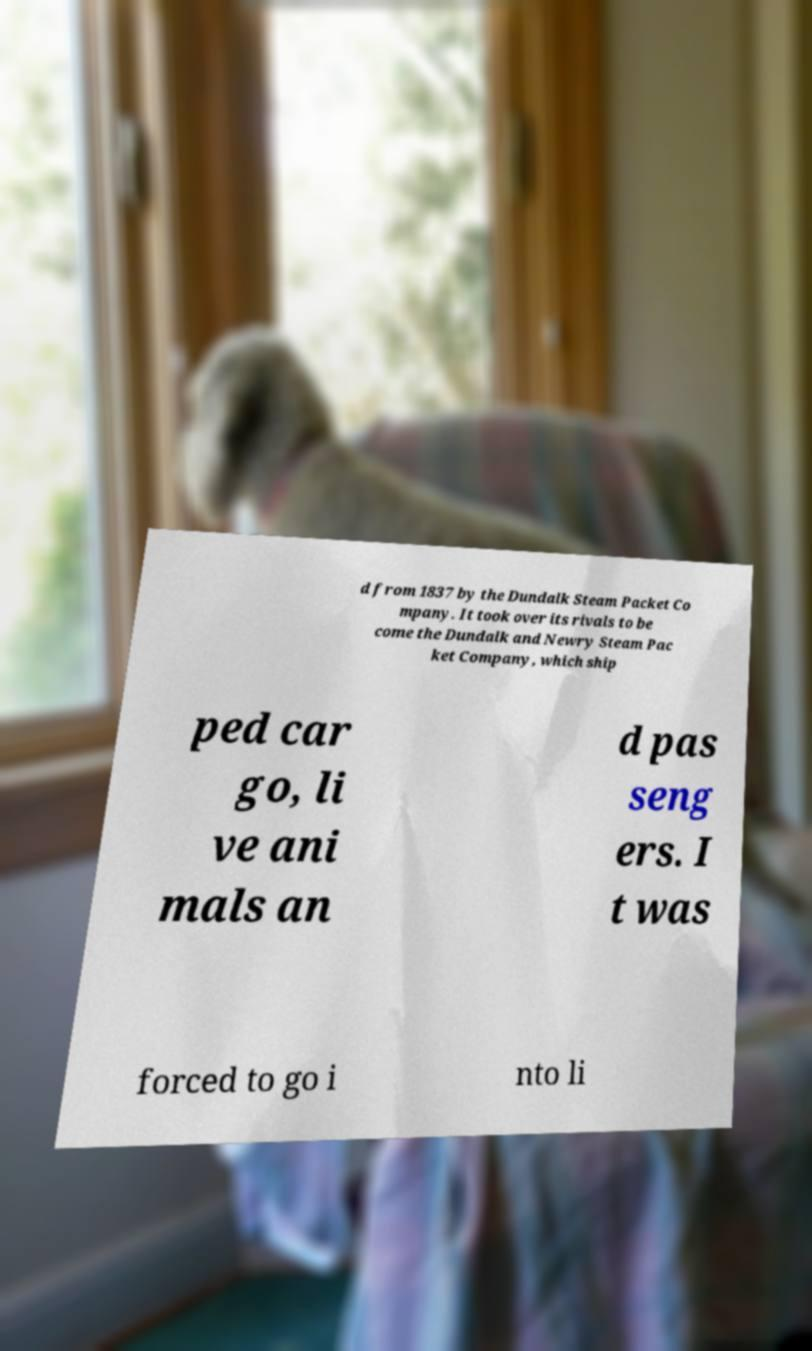Can you read and provide the text displayed in the image?This photo seems to have some interesting text. Can you extract and type it out for me? d from 1837 by the Dundalk Steam Packet Co mpany. It took over its rivals to be come the Dundalk and Newry Steam Pac ket Company, which ship ped car go, li ve ani mals an d pas seng ers. I t was forced to go i nto li 